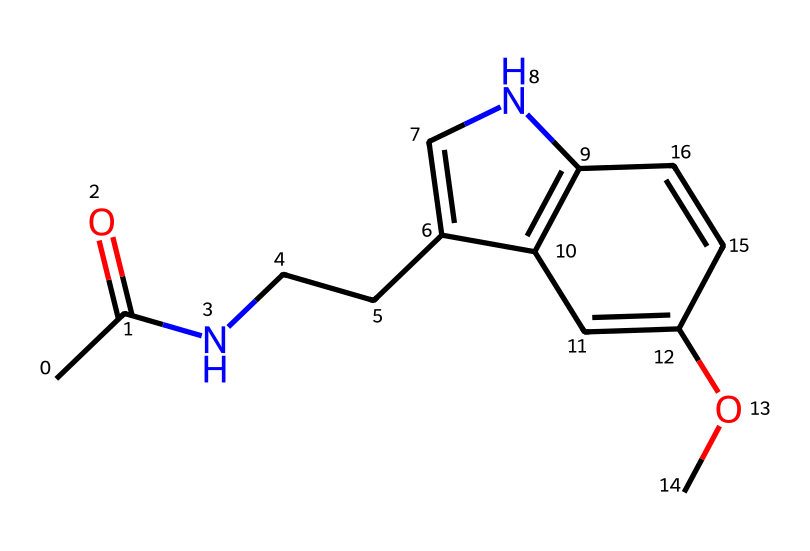What is the molecular formula of melatonin? To determine the molecular formula, we count the atoms of each element present in the SMILES representation. The breakdown shows there are 13 carbon (C), 16 hydrogen (H), 1 nitrogen (N), and 2 oxygen (O) atoms. Thus, the formula is C13H16N2O2.
Answer: C13H16N2O2 How many rings are present in the structure of melatonin? By analyzing the SMILES representation, we observe that there is one cyclic structure indicated by the presence of '1' in the representation. The '1' indicates where the ring begins and ends, confirming there is one ring in the chemical structure.
Answer: 1 What is the primary functional group present in melatonin? The presence of the acetyl group (CC(=O)N) in the structure indicates that the primary functional group is an amide. An amide consists of a carbonyl (C=O) adjacent to a nitrogen atom, which is present in the structure.
Answer: amide Which component of the structure indicates its role as a hormone? The presence of the indole structure (indicated by the conjugated ring system involving nitrogen and carbon atoms) in the SMILES format is characteristic of many hormones including melatonin. This indole structure is key to its functional role.
Answer: indole What type of bonding is predominantly present in melatonin? The presence of single and double bonds, primarily within the carbon backbone, and between the oxygen and carbon in the carbonyl group suggests that covalent bonding is predominant in the structure. Covalent bonds form the stable structural framework of the molecule.
Answer: covalent Which atom is responsible for the nitrogen in melatonin? The 'N' present in the structure indicates that nitrogen is part of the amine functional group (linked to the carbon chain) and also part of the indole structure. This atom is essential for the hormone's activity within biological systems.
Answer: nitrogen 